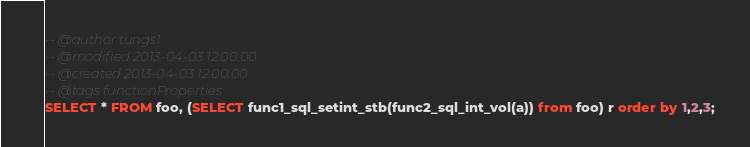<code> <loc_0><loc_0><loc_500><loc_500><_SQL_>-- @author tungs1
-- @modified 2013-04-03 12:00:00
-- @created 2013-04-03 12:00:00
-- @tags functionProperties 
SELECT * FROM foo, (SELECT func1_sql_setint_stb(func2_sql_int_vol(a)) from foo) r order by 1,2,3; 
</code> 